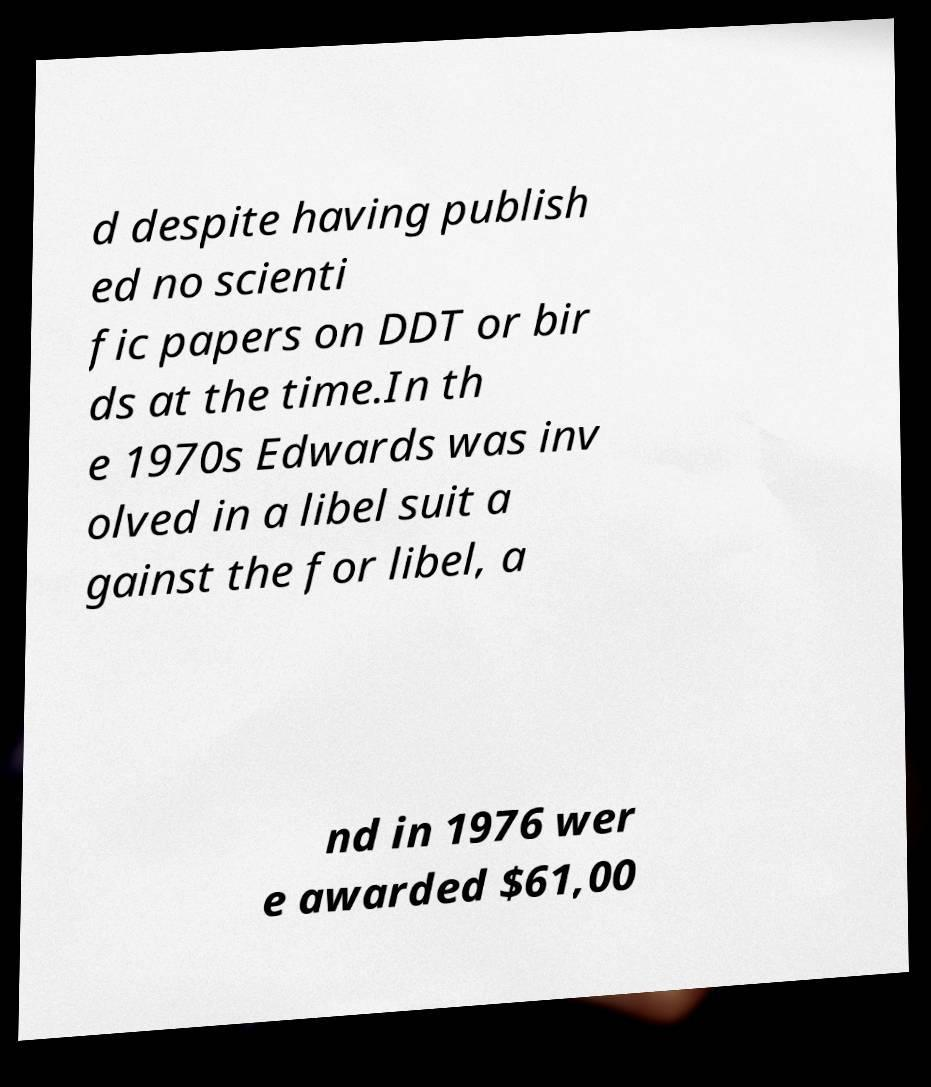Please read and relay the text visible in this image. What does it say? d despite having publish ed no scienti fic papers on DDT or bir ds at the time.In th e 1970s Edwards was inv olved in a libel suit a gainst the for libel, a nd in 1976 wer e awarded $61,00 